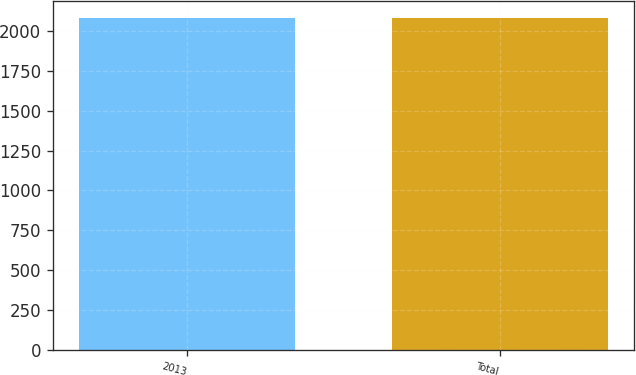Convert chart to OTSL. <chart><loc_0><loc_0><loc_500><loc_500><bar_chart><fcel>2013<fcel>Total<nl><fcel>2083<fcel>2083.1<nl></chart> 